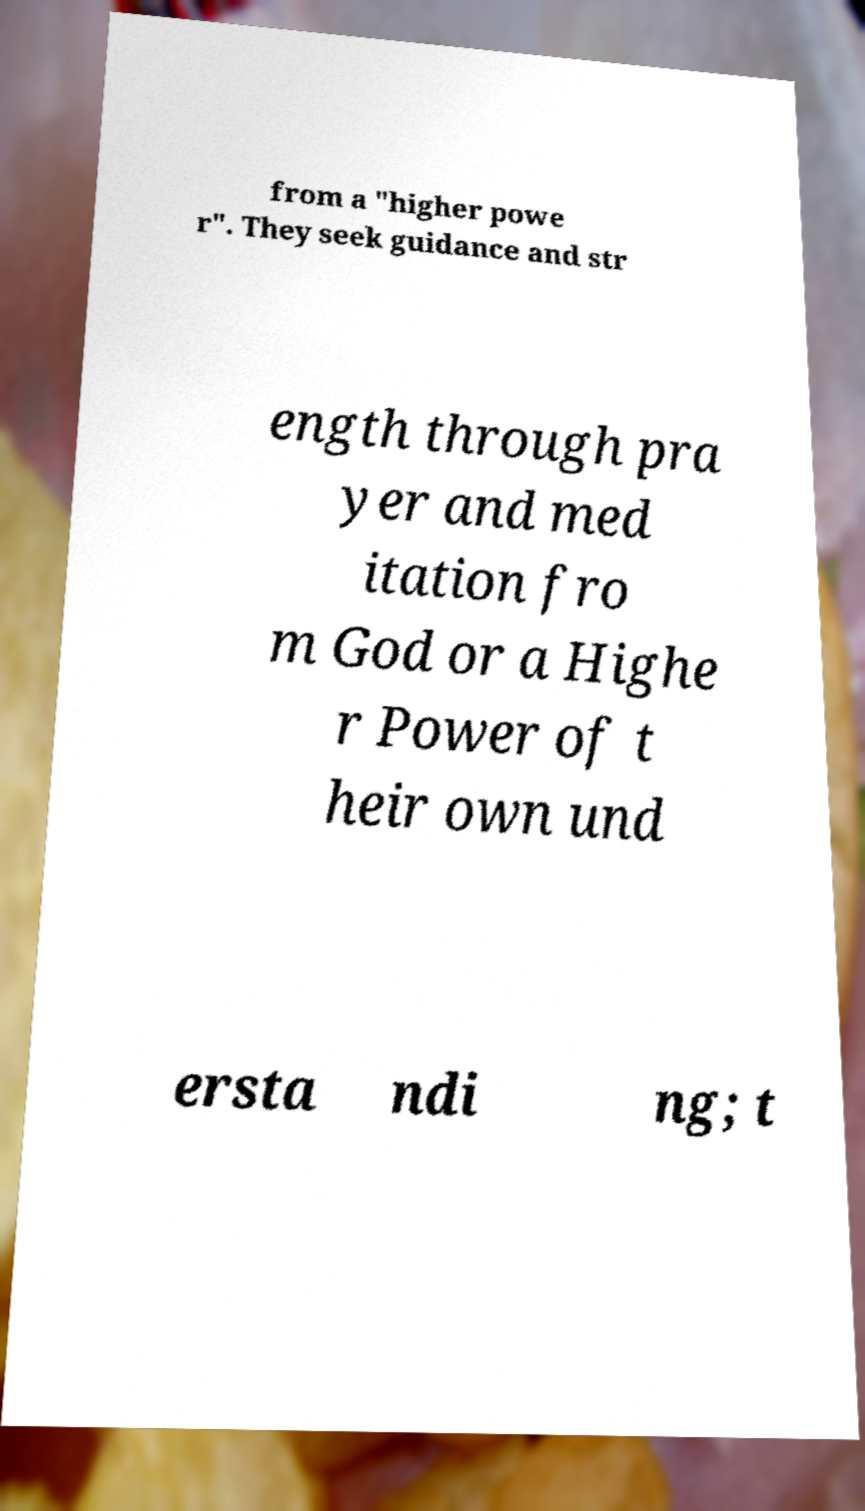I need the written content from this picture converted into text. Can you do that? from a "higher powe r". They seek guidance and str ength through pra yer and med itation fro m God or a Highe r Power of t heir own und ersta ndi ng; t 